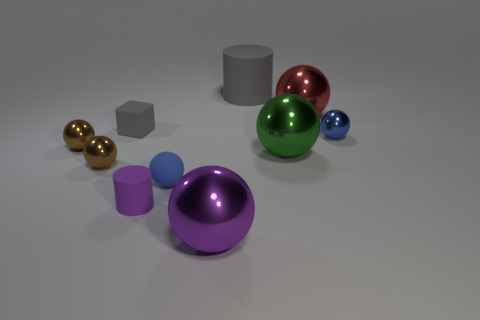Subtract all brown metal spheres. How many spheres are left? 5 Add 6 purple shiny spheres. How many purple shiny spheres are left? 7 Add 4 tiny blue spheres. How many tiny blue spheres exist? 6 Subtract all purple cylinders. How many cylinders are left? 1 Subtract 0 yellow balls. How many objects are left? 10 Subtract all blocks. How many objects are left? 9 Subtract 1 spheres. How many spheres are left? 6 Subtract all green blocks. Subtract all cyan spheres. How many blocks are left? 1 Subtract all blue balls. How many purple cylinders are left? 1 Subtract all small purple things. Subtract all large gray rubber cylinders. How many objects are left? 8 